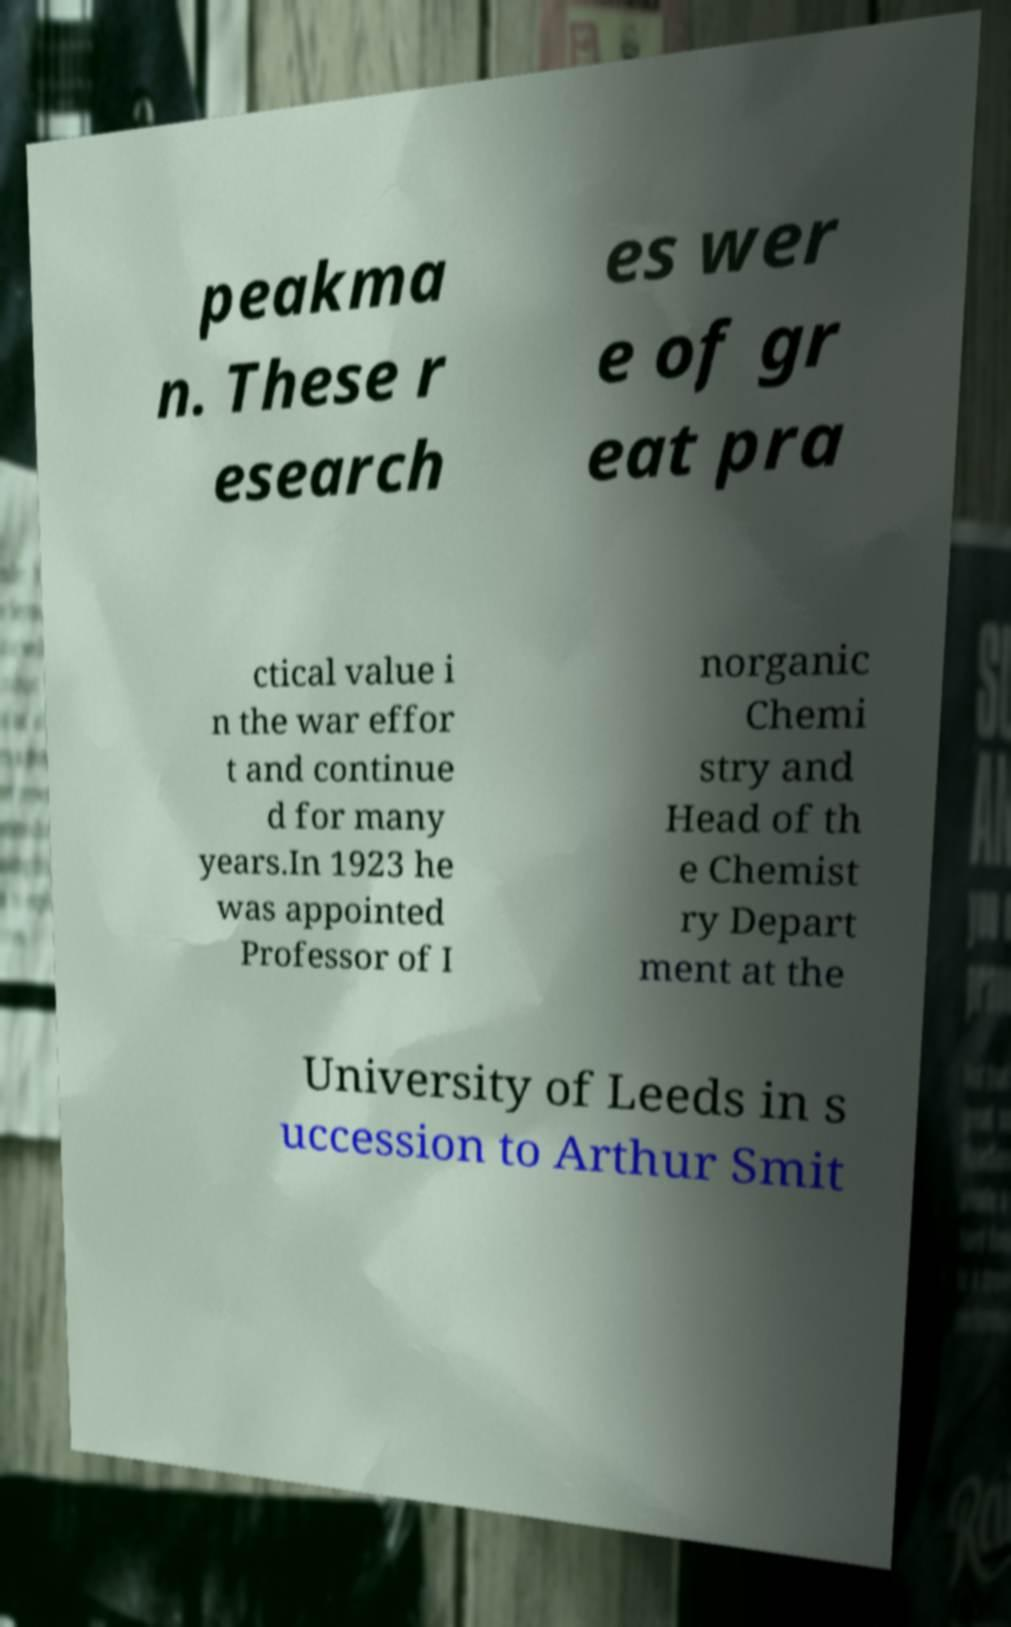Could you assist in decoding the text presented in this image and type it out clearly? peakma n. These r esearch es wer e of gr eat pra ctical value i n the war effor t and continue d for many years.In 1923 he was appointed Professor of I norganic Chemi stry and Head of th e Chemist ry Depart ment at the University of Leeds in s uccession to Arthur Smit 